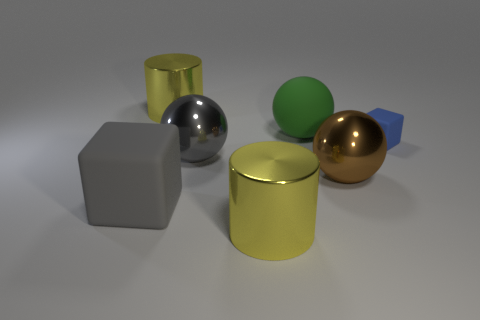Are there any big cylinders to the right of the blue cube?
Your answer should be compact. No. There is a big object that is the same color as the big block; what is its shape?
Your response must be concise. Sphere. What number of things are either objects that are in front of the tiny blue matte block or tiny matte objects?
Offer a very short reply. 5. The blue cube that is the same material as the green ball is what size?
Give a very brief answer. Small. Do the gray ball and the yellow metal thing that is in front of the large green sphere have the same size?
Offer a terse response. Yes. What color is the sphere that is in front of the blue rubber object and right of the big gray shiny sphere?
Your response must be concise. Brown. What number of objects are either rubber cubes behind the large gray shiny thing or tiny blue cubes that are to the right of the gray rubber cube?
Keep it short and to the point. 1. What is the color of the big metal ball right of the big yellow thing that is to the right of the big yellow shiny cylinder behind the large brown metal object?
Your response must be concise. Brown. Is there a small blue object of the same shape as the large gray matte object?
Offer a terse response. Yes. What number of rubber things are there?
Make the answer very short. 3. 